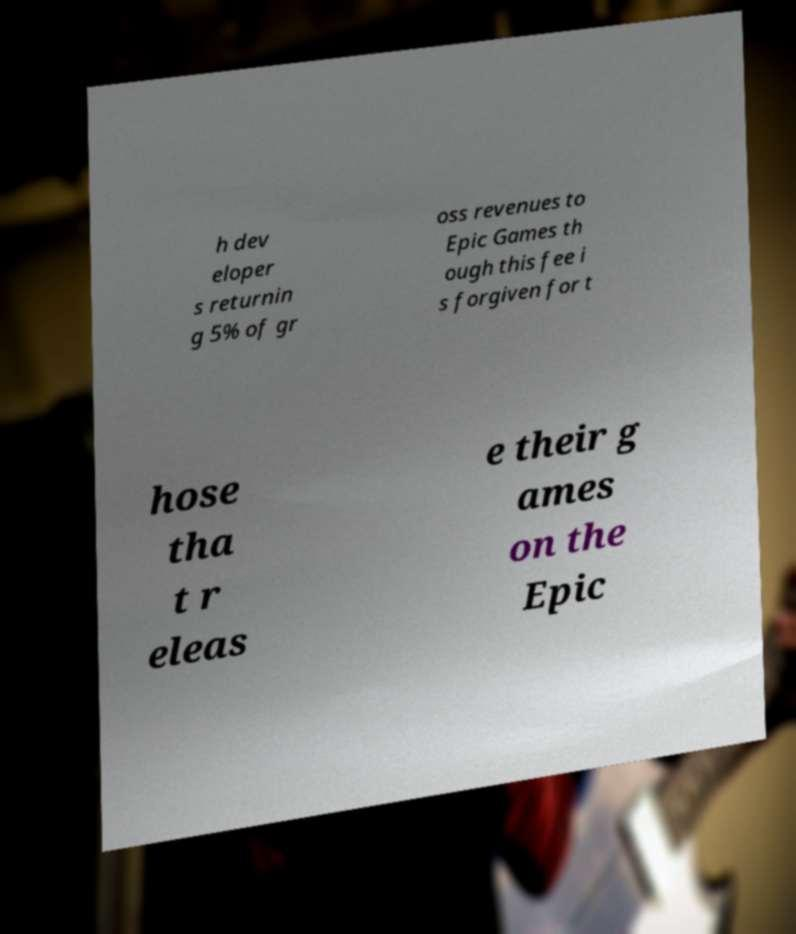I need the written content from this picture converted into text. Can you do that? h dev eloper s returnin g 5% of gr oss revenues to Epic Games th ough this fee i s forgiven for t hose tha t r eleas e their g ames on the Epic 